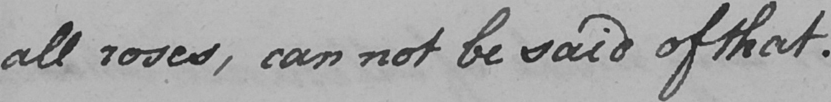What is written in this line of handwriting? all roses , can not be said of that . 